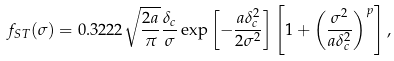Convert formula to latex. <formula><loc_0><loc_0><loc_500><loc_500>f _ { S T } ( \sigma ) = 0 . 3 2 2 2 \sqrt { \frac { 2 a } { \pi } } \frac { \delta _ { c } } { \sigma } \exp \left [ - \frac { a \delta ^ { 2 } _ { c } } { 2 \sigma ^ { 2 } } \right ] \left [ 1 + \left ( \frac { \sigma ^ { 2 } } { a \delta ^ { 2 } _ { c } } \right ) ^ { p } \right ] ,</formula> 